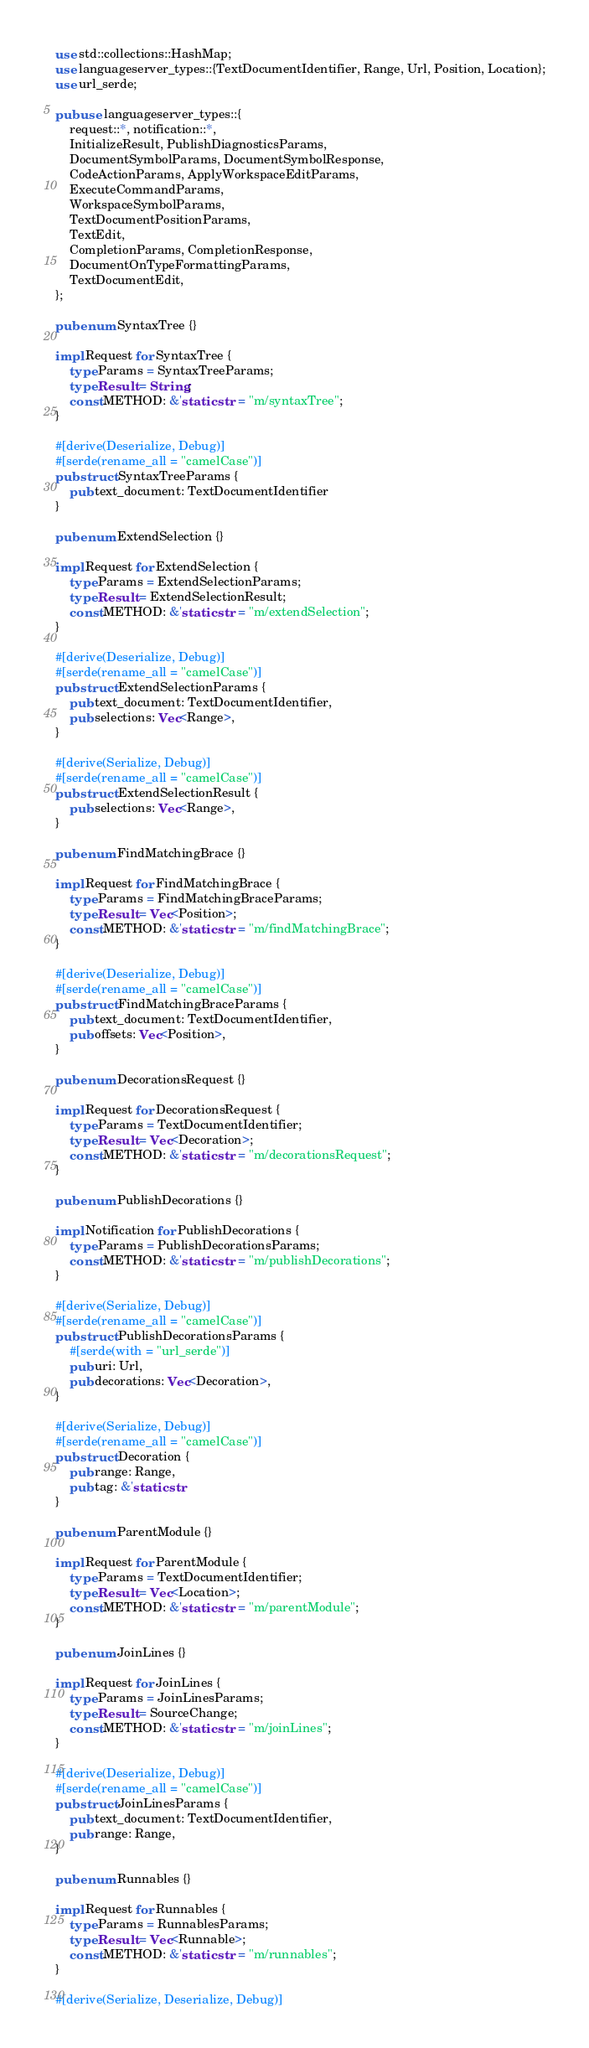<code> <loc_0><loc_0><loc_500><loc_500><_Rust_>use std::collections::HashMap;
use languageserver_types::{TextDocumentIdentifier, Range, Url, Position, Location};
use url_serde;

pub use languageserver_types::{
    request::*, notification::*,
    InitializeResult, PublishDiagnosticsParams,
    DocumentSymbolParams, DocumentSymbolResponse,
    CodeActionParams, ApplyWorkspaceEditParams,
    ExecuteCommandParams,
    WorkspaceSymbolParams,
    TextDocumentPositionParams,
    TextEdit,
    CompletionParams, CompletionResponse,
    DocumentOnTypeFormattingParams,
    TextDocumentEdit,
};

pub enum SyntaxTree {}

impl Request for SyntaxTree {
    type Params = SyntaxTreeParams;
    type Result = String;
    const METHOD: &'static str = "m/syntaxTree";
}

#[derive(Deserialize, Debug)]
#[serde(rename_all = "camelCase")]
pub struct SyntaxTreeParams {
    pub text_document: TextDocumentIdentifier
}

pub enum ExtendSelection {}

impl Request for ExtendSelection {
    type Params = ExtendSelectionParams;
    type Result = ExtendSelectionResult;
    const METHOD: &'static str = "m/extendSelection";
}

#[derive(Deserialize, Debug)]
#[serde(rename_all = "camelCase")]
pub struct ExtendSelectionParams {
    pub text_document: TextDocumentIdentifier,
    pub selections: Vec<Range>,
}

#[derive(Serialize, Debug)]
#[serde(rename_all = "camelCase")]
pub struct ExtendSelectionResult {
    pub selections: Vec<Range>,
}

pub enum FindMatchingBrace {}

impl Request for FindMatchingBrace {
    type Params = FindMatchingBraceParams;
    type Result = Vec<Position>;
    const METHOD: &'static str = "m/findMatchingBrace";
}

#[derive(Deserialize, Debug)]
#[serde(rename_all = "camelCase")]
pub struct FindMatchingBraceParams {
    pub text_document: TextDocumentIdentifier,
    pub offsets: Vec<Position>,
}

pub enum DecorationsRequest {}

impl Request for DecorationsRequest {
    type Params = TextDocumentIdentifier;
    type Result = Vec<Decoration>;
    const METHOD: &'static str = "m/decorationsRequest";
}

pub enum PublishDecorations {}

impl Notification for PublishDecorations {
    type Params = PublishDecorationsParams;
    const METHOD: &'static str = "m/publishDecorations";
}

#[derive(Serialize, Debug)]
#[serde(rename_all = "camelCase")]
pub struct PublishDecorationsParams {
    #[serde(with = "url_serde")]
    pub uri: Url,
    pub decorations: Vec<Decoration>,
}

#[derive(Serialize, Debug)]
#[serde(rename_all = "camelCase")]
pub struct Decoration {
    pub range: Range,
    pub tag: &'static str
}

pub enum ParentModule {}

impl Request for ParentModule {
    type Params = TextDocumentIdentifier;
    type Result = Vec<Location>;
    const METHOD: &'static str = "m/parentModule";
}

pub enum JoinLines {}

impl Request for JoinLines {
    type Params = JoinLinesParams;
    type Result = SourceChange;
    const METHOD: &'static str = "m/joinLines";
}

#[derive(Deserialize, Debug)]
#[serde(rename_all = "camelCase")]
pub struct JoinLinesParams {
    pub text_document: TextDocumentIdentifier,
    pub range: Range,
}

pub enum Runnables {}

impl Request for Runnables {
    type Params = RunnablesParams;
    type Result = Vec<Runnable>;
    const METHOD: &'static str = "m/runnables";
}

#[derive(Serialize, Deserialize, Debug)]</code> 